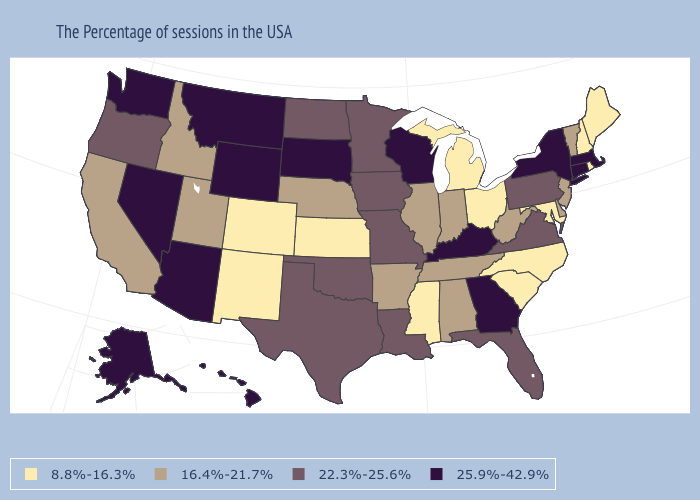Name the states that have a value in the range 22.3%-25.6%?
Answer briefly. Pennsylvania, Virginia, Florida, Louisiana, Missouri, Minnesota, Iowa, Oklahoma, Texas, North Dakota, Oregon. How many symbols are there in the legend?
Concise answer only. 4. Does Montana have the highest value in the USA?
Give a very brief answer. Yes. What is the value of Minnesota?
Answer briefly. 22.3%-25.6%. What is the highest value in the USA?
Give a very brief answer. 25.9%-42.9%. What is the value of Alabama?
Keep it brief. 16.4%-21.7%. What is the value of Missouri?
Quick response, please. 22.3%-25.6%. Which states have the lowest value in the USA?
Give a very brief answer. Maine, Rhode Island, New Hampshire, Maryland, North Carolina, South Carolina, Ohio, Michigan, Mississippi, Kansas, Colorado, New Mexico. How many symbols are there in the legend?
Be succinct. 4. How many symbols are there in the legend?
Give a very brief answer. 4. Does Missouri have the highest value in the MidWest?
Write a very short answer. No. Does Alabama have a higher value than Colorado?
Be succinct. Yes. Among the states that border Louisiana , does Texas have the highest value?
Quick response, please. Yes. How many symbols are there in the legend?
Be succinct. 4. Name the states that have a value in the range 25.9%-42.9%?
Short answer required. Massachusetts, Connecticut, New York, Georgia, Kentucky, Wisconsin, South Dakota, Wyoming, Montana, Arizona, Nevada, Washington, Alaska, Hawaii. 